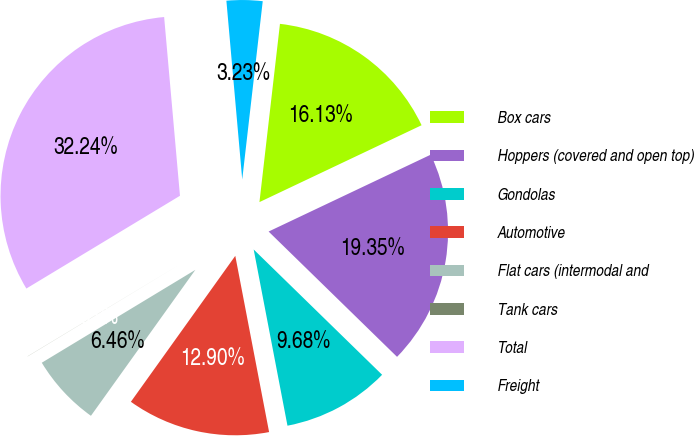Convert chart to OTSL. <chart><loc_0><loc_0><loc_500><loc_500><pie_chart><fcel>Box cars<fcel>Hoppers (covered and open top)<fcel>Gondolas<fcel>Automotive<fcel>Flat cars (intermodal and<fcel>Tank cars<fcel>Total<fcel>Freight<nl><fcel>16.13%<fcel>19.35%<fcel>9.68%<fcel>12.9%<fcel>6.46%<fcel>0.01%<fcel>32.24%<fcel>3.23%<nl></chart> 